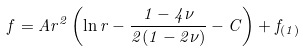Convert formula to latex. <formula><loc_0><loc_0><loc_500><loc_500>f = A r ^ { 2 } \left ( \ln r - \frac { 1 - 4 \nu } { 2 ( 1 - 2 \nu ) } - C \right ) + f _ { ( 1 ) }</formula> 